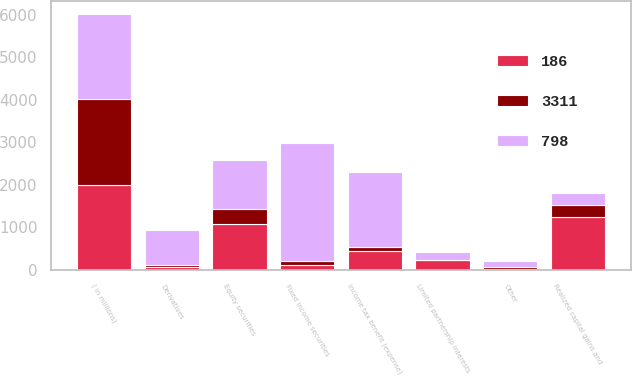Convert chart. <chart><loc_0><loc_0><loc_500><loc_500><stacked_bar_chart><ecel><fcel>( in millions)<fcel>Fixed income securities<fcel>Equity securities<fcel>Limited partnership interests<fcel>Derivatives<fcel>Other<fcel>Realized capital gains and<fcel>Income tax benefit (expense)<nl><fcel>798<fcel>2008<fcel>2781<fcel>1149<fcel>194<fcel>821<fcel>145<fcel>286<fcel>1779<nl><fcel>186<fcel>2007<fcel>126<fcel>1086<fcel>225<fcel>62<fcel>12<fcel>1235<fcel>437<nl><fcel>3311<fcel>2006<fcel>87<fcel>360<fcel>11<fcel>46<fcel>48<fcel>286<fcel>100<nl></chart> 